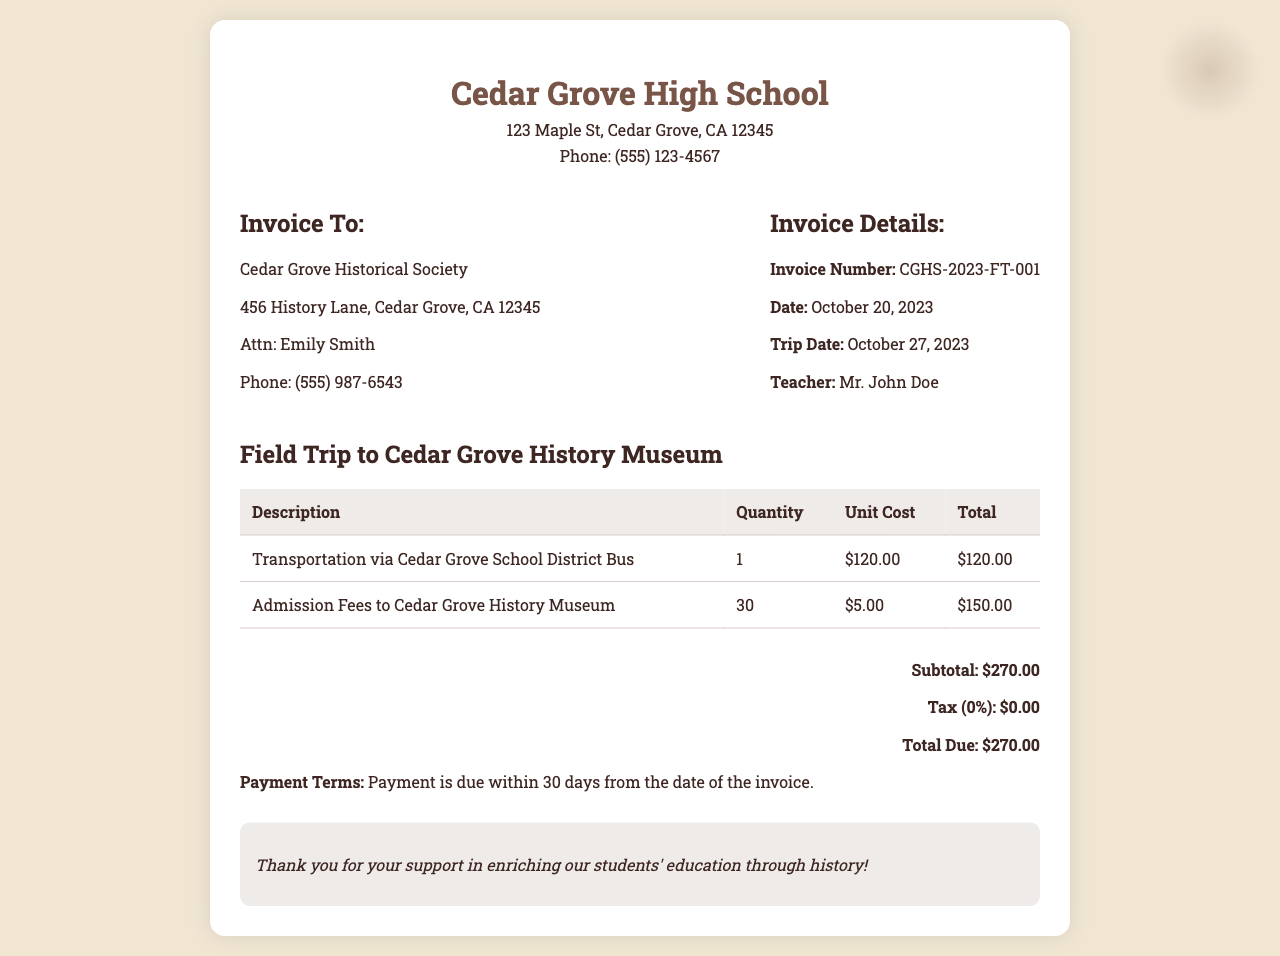What is the invoice number? The invoice number is a unique identifier for this specific invoice, found in the invoice details section.
Answer: CGHS-2023-FT-001 What is the date of the trip? The trip date is specified in the invoice details, indicating when the field trip will occur.
Answer: October 27, 2023 Who is the invoice addressed to? The document lists the recipient of the invoice in the "Invoice To" section, which is the Cedar Grove Historical Society.
Answer: Cedar Grove Historical Society What is the total due amount? The total amount owed is calculated and presented at the bottom of the invoice.
Answer: $270.00 How many students' admission fees are included? The quantity for admission fees in the invoice indicates how many students are accounted for.
Answer: 30 What kind of transportation is listed? The document specifies the type of transportation used for the field trip in the list of items.
Answer: Cedar Grove School District Bus What is the subtotal before tax? The subtotal is calculated before any taxes are applied and is indicated in the total section.
Answer: $270.00 What is the payment term for this invoice? The payment terms are outlined towards the end of the document, specifying when payment should be made.
Answer: Payment is due within 30 days from the date of the invoice What does the invoice express gratitude for? The notes section at the bottom of the invoice highlights the purpose for gratitude expressed by the invoicer.
Answer: Enriching our students' education through history! 